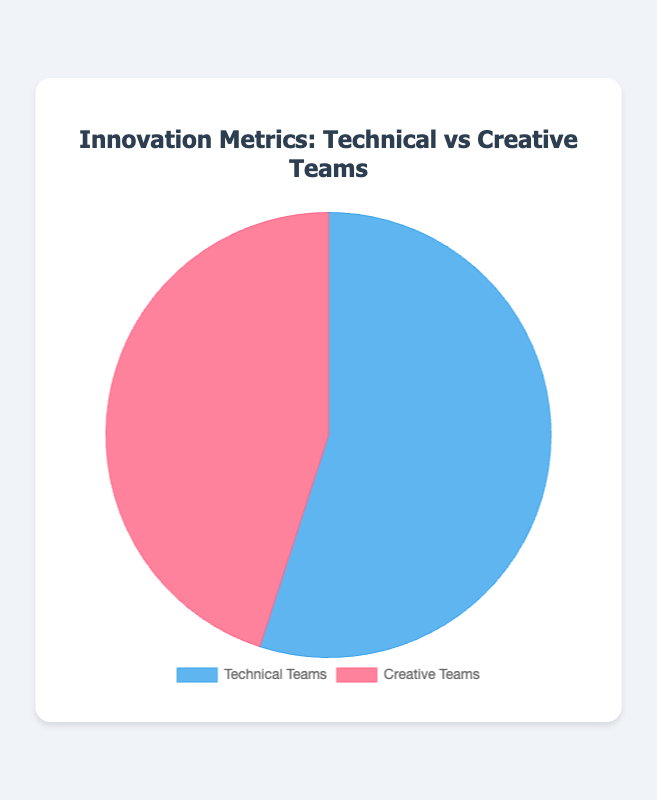Which type of skill utilization is more prevalent among employees? The pie chart shows two categories: Specialized Skills and General Skills. By comparing the percentages, we can see that Specialized Skills (65%) is greater than General Skills (35%).
Answer: Specialized Skills What's the difference in skill utilization between specialized skills and general skills? The chart shows that 65% of employees utilize specialized skills while 35% utilize general skills. The difference is calculated as 65% - 35% = 30%.
Answer: 30% Which team has a higher percentage of initiated projects, technical or creative? By observing the pie chart, we can see that the technical teams have initiated 55% of the projects, which is higher than the 45% initiated by the creative teams.
Answer: Technical teams If the goal is to balance the skill utilization, by what percentage should the employees utilizing specialized skills decrease and those utilizing general skills increase? To find the balance, both categories should ideally be 50%. Specialized skills currently account for 65%, so it needs to decrease by 65% - 50% = 15%. General skills are currently at 35%, so they need to increase by 50% - 35% = 15%.
Answer: Specialized: decrease by 15%; General: increase by 15% What is the combined percentage of skill utilization for both specialized and general skills? The pie chart shows the two categories: Specialized Skills (65%) and General Skills (35%). Summing these values, 65% + 35%, gives us 100%.
Answer: 100% Which category represents a smaller portion of the pie, technical teams' projects or general skills utilization? Observing the two pie charts reveals that general skills utilization (35%) is smaller than technical teams' projects (55%).
Answer: General skills utilization Compare the visual representation of specialized skills utilization and projects initiated by creative teams. Which has a larger portion of their respective pie charts, and by how much? Specialized skills utilization is 65%, and projects by creative teams are 45%. The difference between these two values is 65% - 45% = 20%. Additionally, the visual segment for specialized skills is larger.
Answer: Specialized skills utilization by 20% What can be inferred about the company's emphasis on specialized skills versus innovation by creative teams based on the percentage distribution? The company shows a greater emphasis on specialized skills utilization (65%) compared to the projects initiated by creative teams (45%). This suggests a potential stronger focus on employees with specialized expertise over creative-oriented innovations.
Answer: Emphasis on specialized skills If the portion of creative teams' projects increases by 10%, what will be the new distribution for both teams' projects? If creative teams' projects increase by 10%, they will account for 45% + 10% = 55%. Consequently, technical teams' projects will decrease by the same amount, resulting in 55% - 10% = 45%.
Answer: Creative: 55%; Technical: 45% What's the ratio of specialized skills utilization to general skills utilization? The ratio can be calculated by dividing the percentage of specialized skills utilization (65%) by the percentage of general skills utilization (35%). The ratio is 65/35, which simplifies to approximately 1.86.
Answer: 1.86 